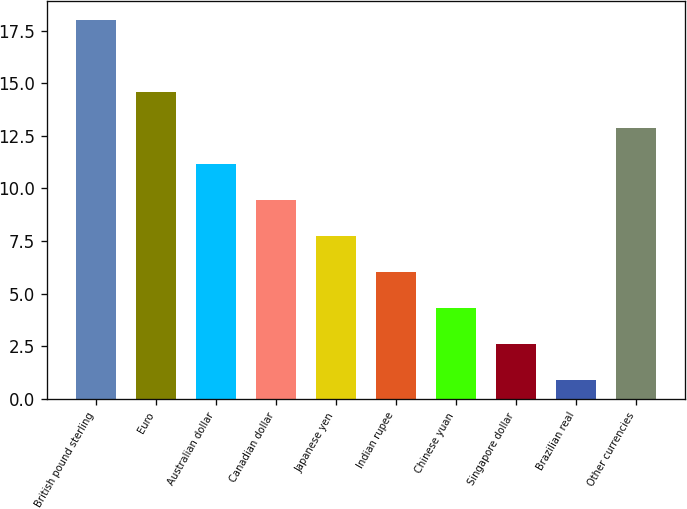Convert chart to OTSL. <chart><loc_0><loc_0><loc_500><loc_500><bar_chart><fcel>British pound sterling<fcel>Euro<fcel>Australian dollar<fcel>Canadian dollar<fcel>Japanese yen<fcel>Indian rupee<fcel>Chinese yuan<fcel>Singapore dollar<fcel>Brazilian real<fcel>Other currencies<nl><fcel>18<fcel>14.58<fcel>11.16<fcel>9.45<fcel>7.74<fcel>6.03<fcel>4.32<fcel>2.61<fcel>0.9<fcel>12.87<nl></chart> 